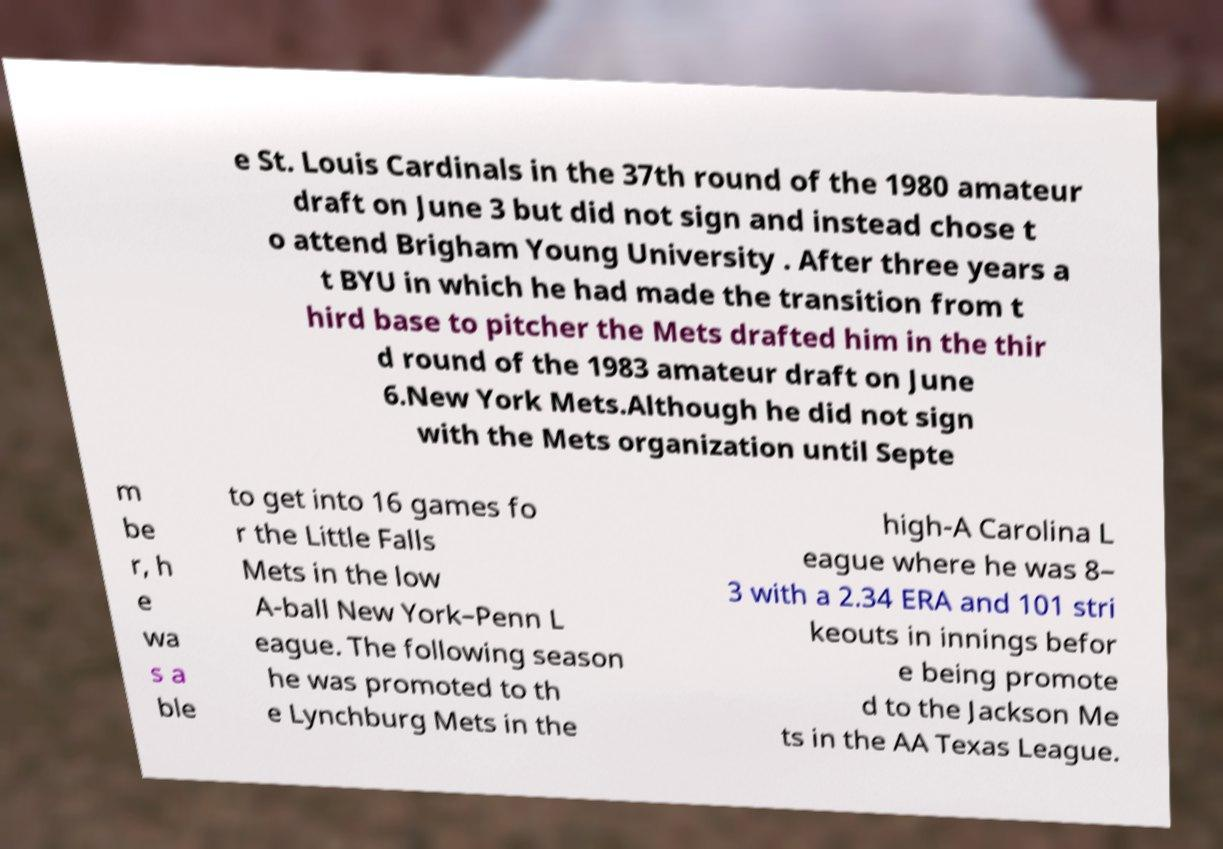Can you read and provide the text displayed in the image?This photo seems to have some interesting text. Can you extract and type it out for me? e St. Louis Cardinals in the 37th round of the 1980 amateur draft on June 3 but did not sign and instead chose t o attend Brigham Young University . After three years a t BYU in which he had made the transition from t hird base to pitcher the Mets drafted him in the thir d round of the 1983 amateur draft on June 6.New York Mets.Although he did not sign with the Mets organization until Septe m be r, h e wa s a ble to get into 16 games fo r the Little Falls Mets in the low A-ball New York–Penn L eague. The following season he was promoted to th e Lynchburg Mets in the high-A Carolina L eague where he was 8– 3 with a 2.34 ERA and 101 stri keouts in innings befor e being promote d to the Jackson Me ts in the AA Texas League. 